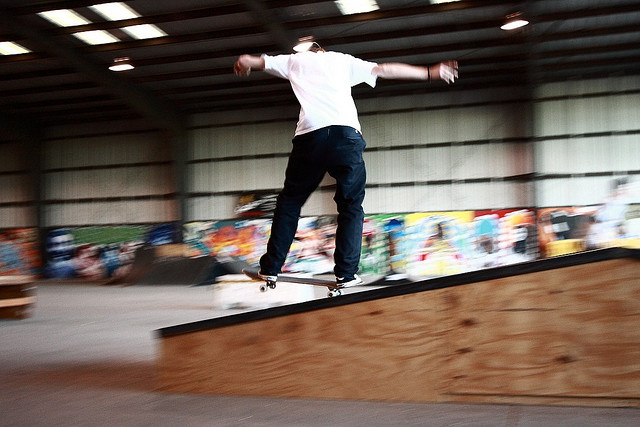Describe the objects in this image and their specific colors. I can see people in black, white, gray, and darkgray tones and skateboard in black, gray, maroon, and darkgray tones in this image. 